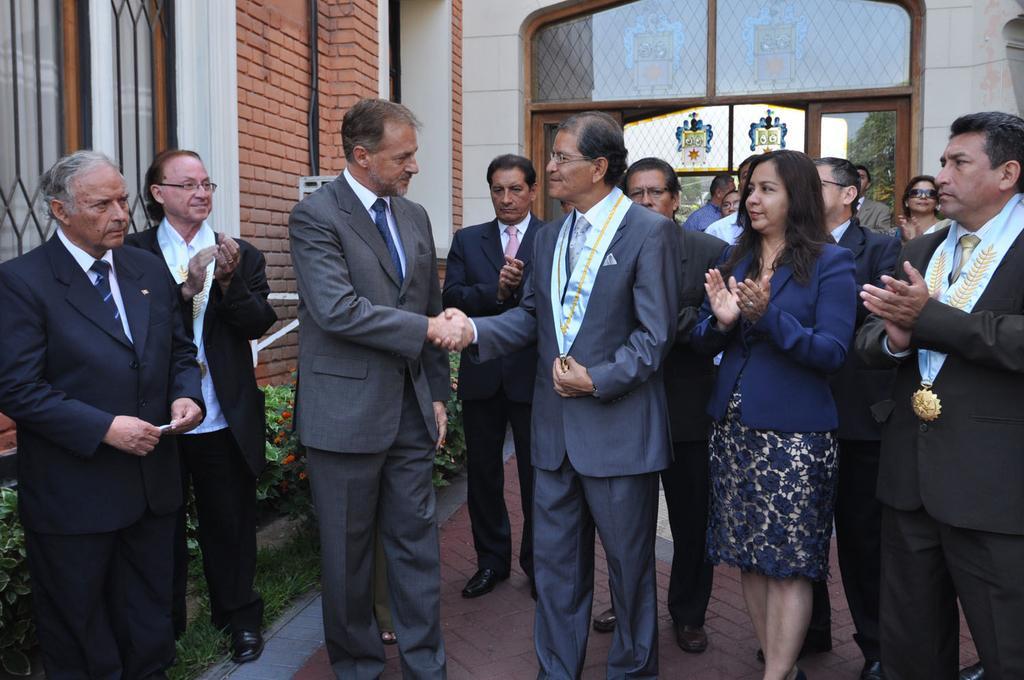Could you give a brief overview of what you see in this image? In this image, we can see persons wearing clothes. There are two persons in the middle of the image shaking hands. There are some plants in the bottom left of the image. In the background of the image, there is a wall. 